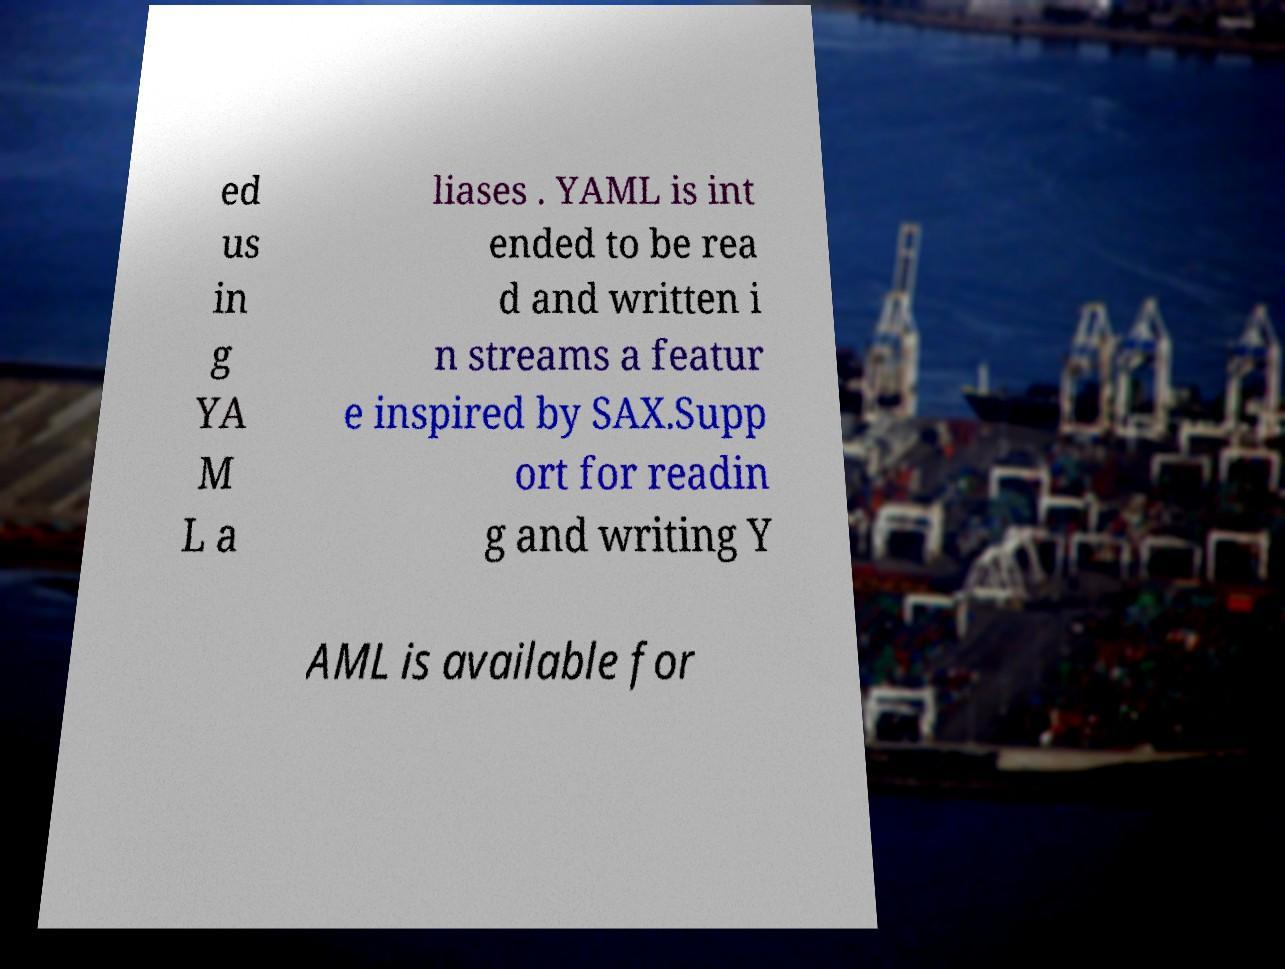Could you assist in decoding the text presented in this image and type it out clearly? ed us in g YA M L a liases . YAML is int ended to be rea d and written i n streams a featur e inspired by SAX.Supp ort for readin g and writing Y AML is available for 